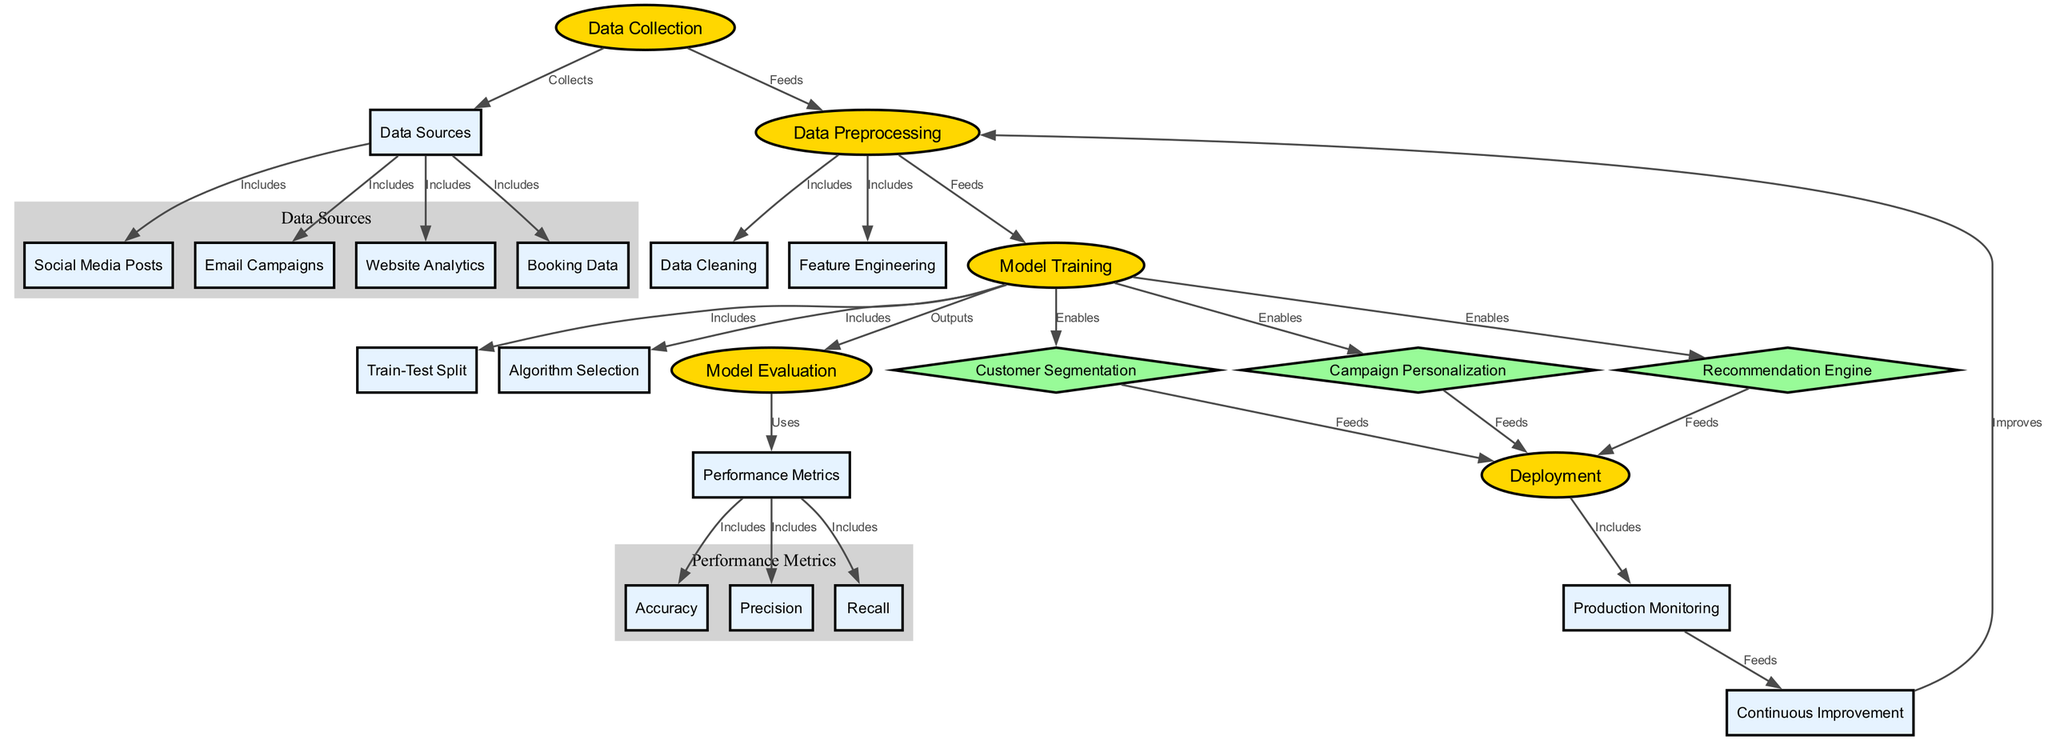What is the first step in the personalized marketing campaign? The diagram indicates that "Data Collection" is the first step, as it is the starting node in the flow.
Answer: Data Collection How many performance metrics are included in the diagram? By counting the nodes connected to "Performance Metrics," there are three metrics: "Accuracy," "Precision," and "Recall."
Answer: 3 Which nodes feed into the deployment? The nodes "Customer Segmentation," "Campaign Personalization," and "Recommendation Engine" all have edges leading to "Deployment," indicating they feed into it.
Answer: Customer Segmentation, Campaign Personalization, Recommendation Engine What does the "Data Preprocessing" node improve? The node "Continuous Improvement" feeds back into "Data Preprocessing," implying that it improves the preprocessing step to enhance the overall model's performance.
Answer: Data Preprocessing Which process uses the "Performance Metrics"? The "Model Evaluation" node uses "Performance Metrics," as indicated by the edge that connects them, showing that evaluation relies on these metrics to assess performance.
Answer: Model Evaluation What comes after "Model Training"? After "Model Training," the next steps are "Customer Segmentation," "Campaign Personalization," and "Recommendation Engine," which enable these processes as outputs of training.
Answer: Customer Segmentation, Campaign Personalization, Recommendation Engine What is included in the "Data Sources"? The "Data Sources" node includes four elements: "Social Media Posts," "Email Campaigns," "Website Analytics," and "Booking Data."
Answer: Social Media Posts, Email Campaigns, Website Analytics, Booking Data How does "Production Monitoring" relate to "Continuous Improvement"? "Production Monitoring" feeds into "Continuous Improvement," meaning that the insights gained from monitoring production are used to facilitate ongoing improvements in the model.
Answer: Continuous Improvement Which node is a diamond-shaped node in the diagram? There are three diamond-shaped nodes: "Customer Segmentation," "Campaign Personalization," and "Recommendation Engine."
Answer: Customer Segmentation, Campaign Personalization, Recommendation Engine 